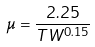Convert formula to latex. <formula><loc_0><loc_0><loc_500><loc_500>\mu = \frac { 2 . 2 5 } { T W ^ { 0 . 1 5 } }</formula> 